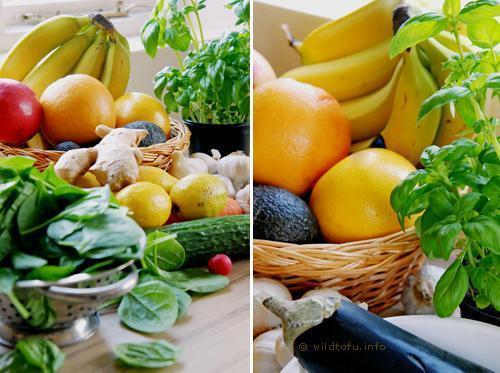How many bananas are visible?
Give a very brief answer. 2. How many oranges are there?
Give a very brief answer. 4. How many birds are in the picture?
Give a very brief answer. 0. 